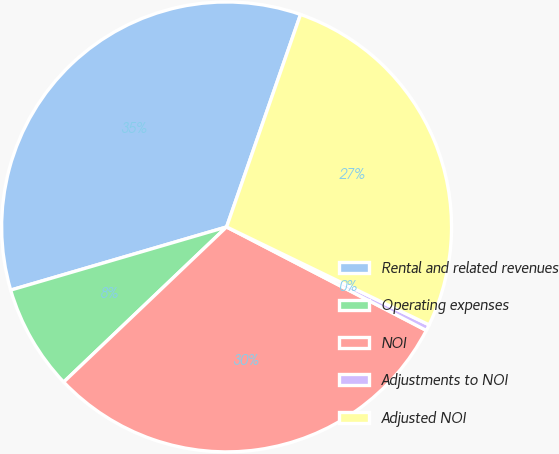Convert chart. <chart><loc_0><loc_0><loc_500><loc_500><pie_chart><fcel>Rental and related revenues<fcel>Operating expenses<fcel>NOI<fcel>Adjustments to NOI<fcel>Adjusted NOI<nl><fcel>34.86%<fcel>7.58%<fcel>30.28%<fcel>0.44%<fcel>26.84%<nl></chart> 